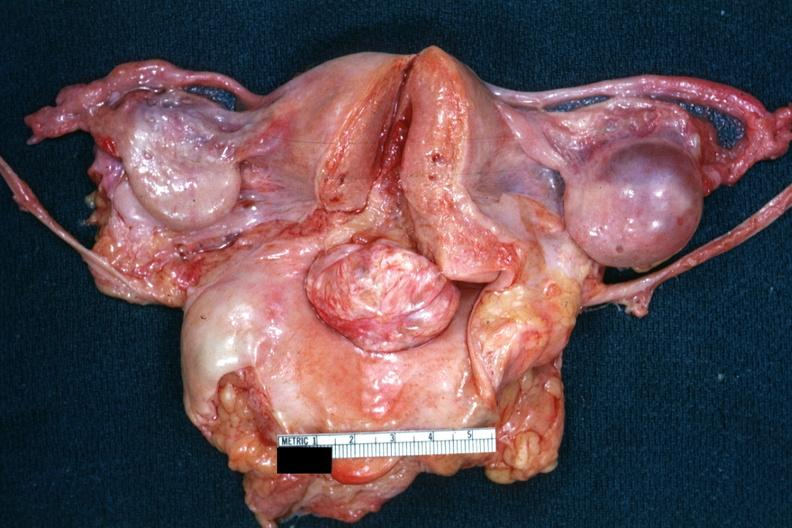s opened uterus and cervix with large cervical myoma protruding into vagina slide close-up of cut surface of this myoma?
Answer the question using a single word or phrase. Yes 